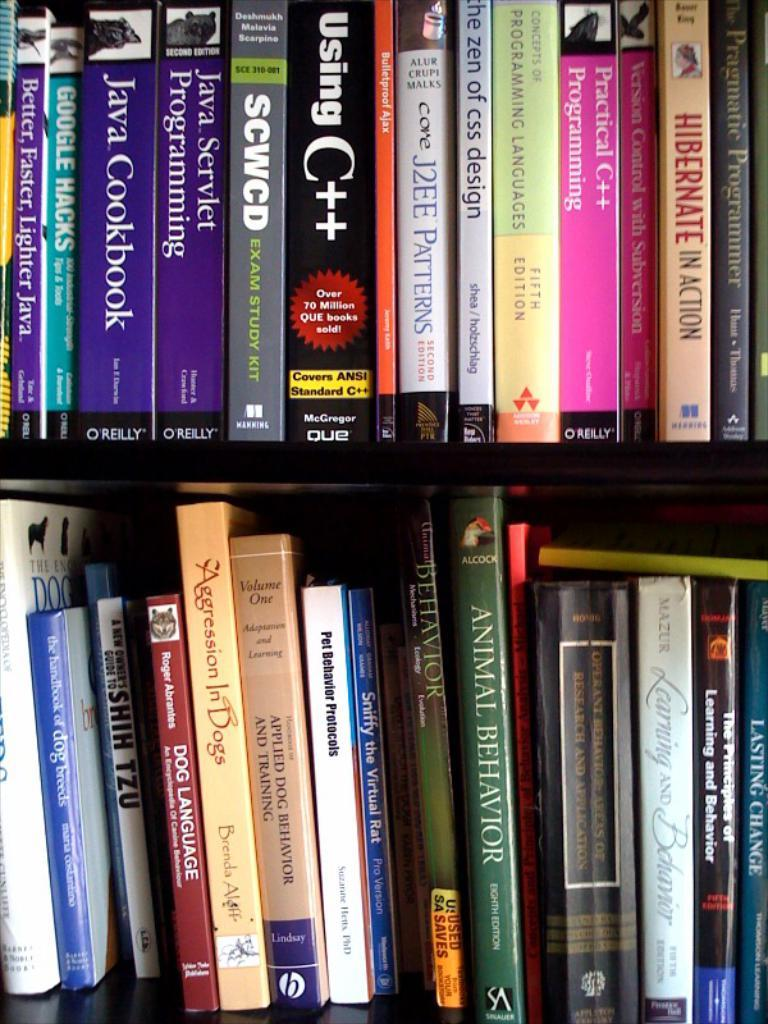<image>
Create a compact narrative representing the image presented. The full shelves of books includes the book "Animal Behavior". 